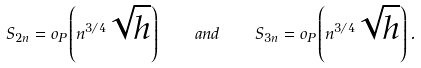<formula> <loc_0><loc_0><loc_500><loc_500>S _ { 2 n } = o _ { P } \left ( n ^ { 3 / 4 } \sqrt { h } \right ) \quad a n d \quad S _ { 3 n } = o _ { P } \left ( n ^ { 3 / 4 } \sqrt { h } \right ) .</formula> 